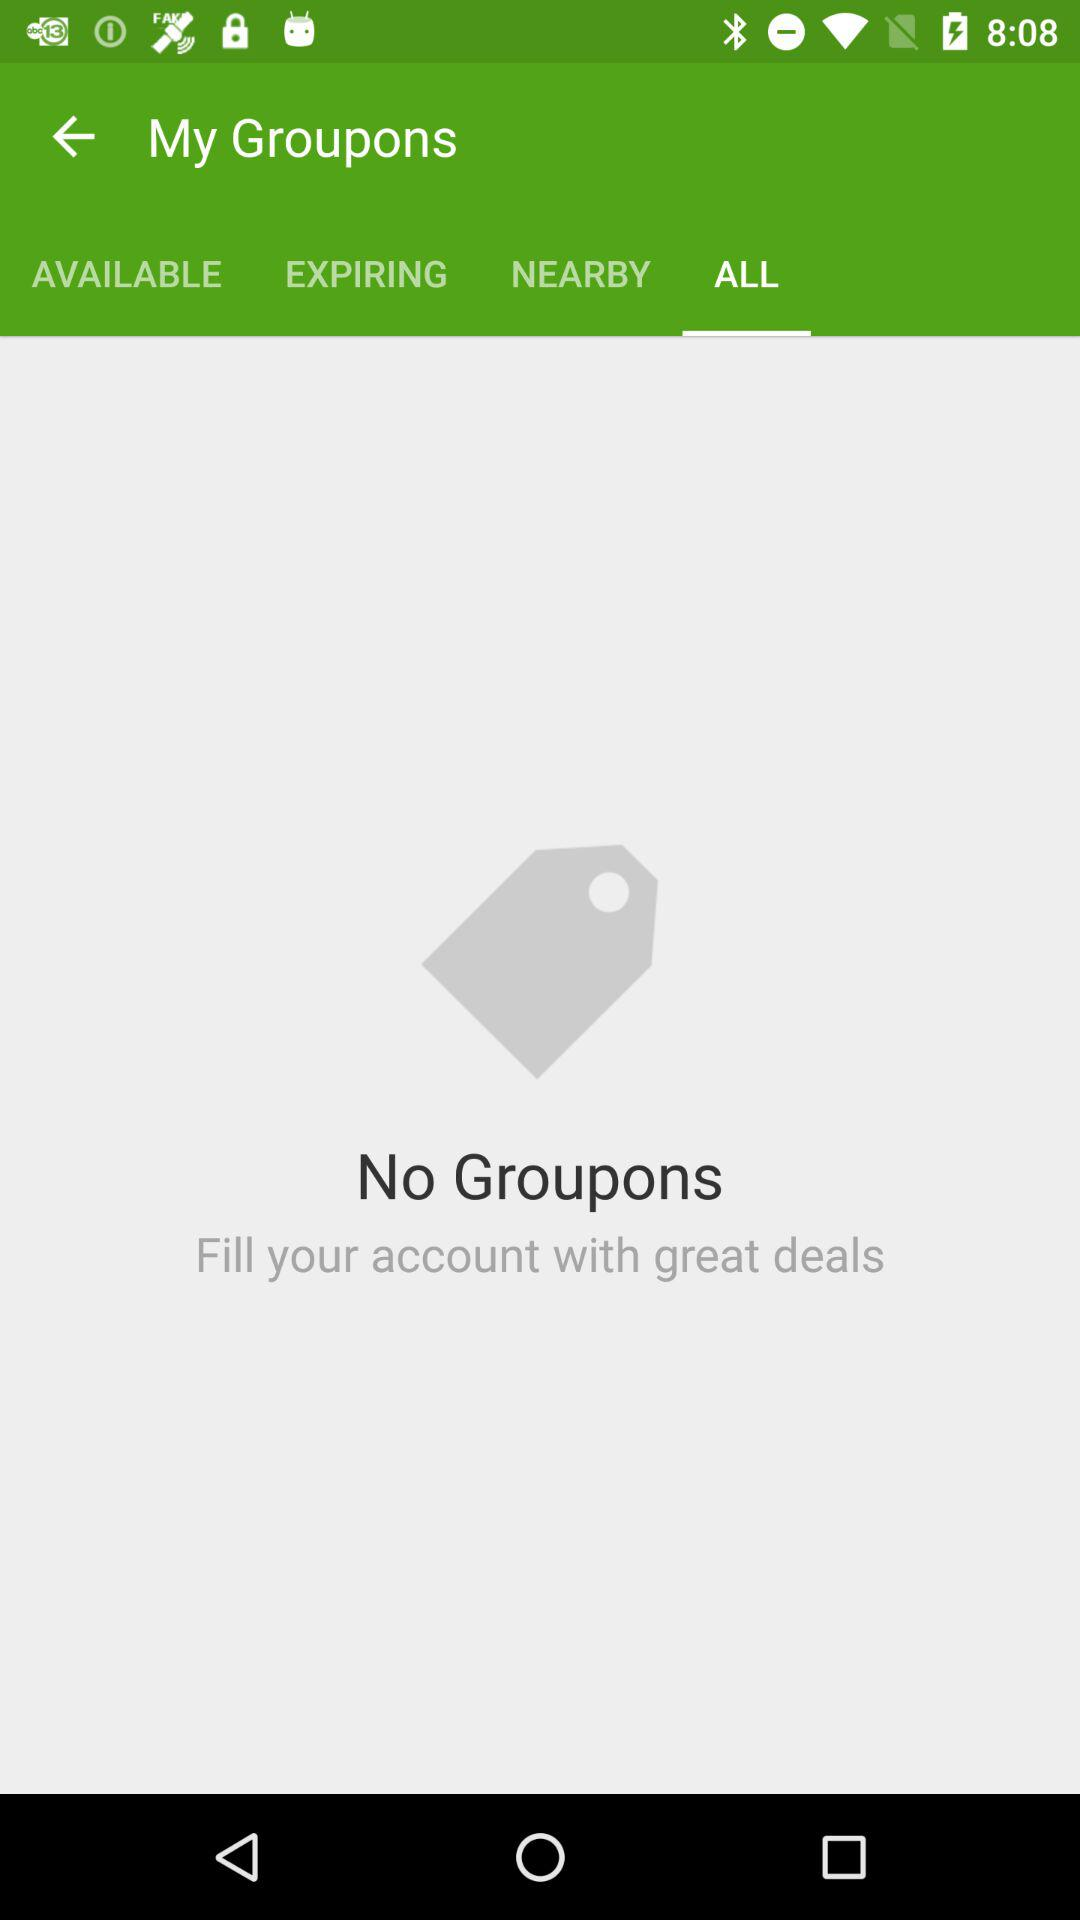How many Groupons are available?
Answer the question using a single word or phrase. 0 